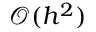Convert formula to latex. <formula><loc_0><loc_0><loc_500><loc_500>\mathcal { O } ( h ^ { 2 } )</formula> 